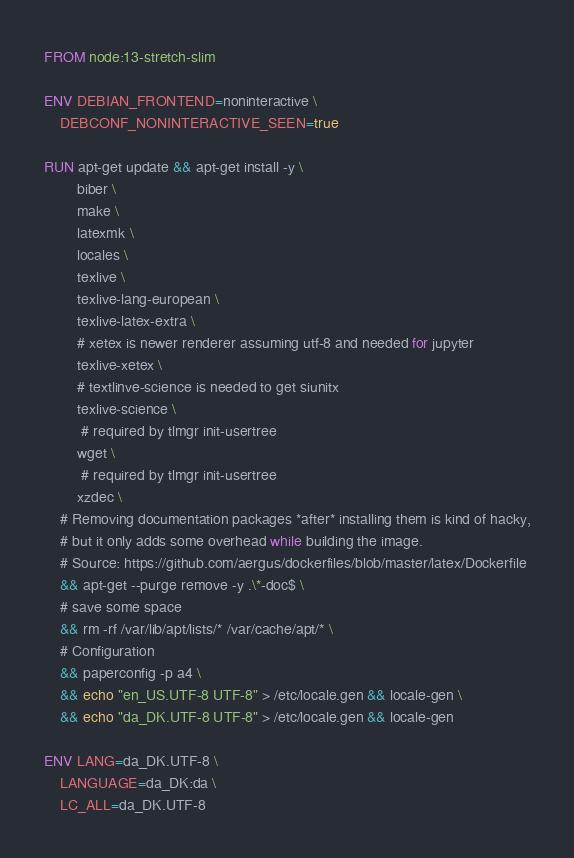<code> <loc_0><loc_0><loc_500><loc_500><_Dockerfile_>FROM node:13-stretch-slim

ENV DEBIAN_FRONTEND=noninteractive \
	DEBCONF_NONINTERACTIVE_SEEN=true
	
RUN apt-get update && apt-get install -y \
		biber \
		make \
		latexmk \
		locales \
		texlive \
		texlive-lang-european \
		texlive-latex-extra \
		# xetex is newer renderer assuming utf-8 and needed for jupyter
		texlive-xetex \
		# textlinve-science is needed to get siunitx
		texlive-science \
		 # required by tlmgr init-usertree
		wget \
		 # required by tlmgr init-usertree
		xzdec \
	# Removing documentation packages *after* installing them is kind of hacky,
    # but it only adds some overhead while building the image.
    # Source: https://github.com/aergus/dockerfiles/blob/master/latex/Dockerfile
    && apt-get --purge remove -y .\*-doc$ \
    # save some space
    && rm -rf /var/lib/apt/lists/* /var/cache/apt/* \
	# Configuration
    && paperconfig -p a4 \
	&& echo "en_US.UTF-8 UTF-8" > /etc/locale.gen && locale-gen \
	&& echo "da_DK.UTF-8 UTF-8" > /etc/locale.gen && locale-gen

ENV LANG=da_DK.UTF-8 \
	LANGUAGE=da_DK:da \
	LC_ALL=da_DK.UTF-8
</code> 